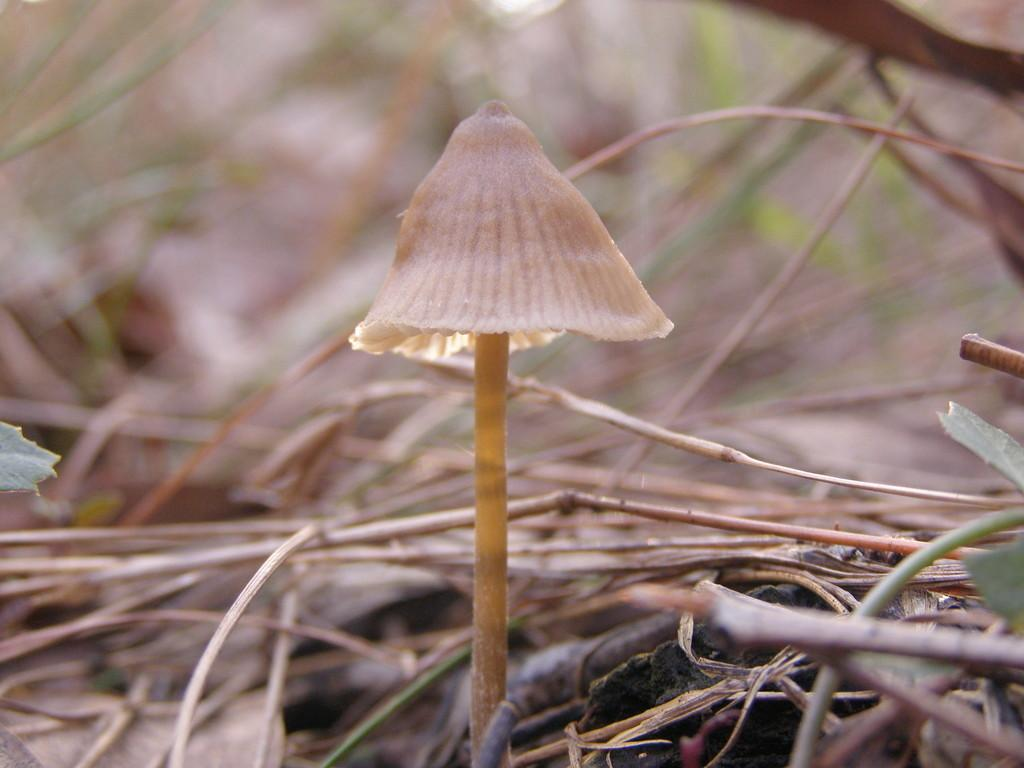What is the main subject in the center of the image? There is a mushroom in the center of the image. What other objects are near the mushroom? There are twigs beside the mushroom. Are there any other natural elements in the image? Yes, there are leaves in the image. How would you describe the background of the image? The background of the image is blurred. How many legs can be seen on the book in the image? There is no book present in the image, so it is not possible to determine the number of legs on a book. 